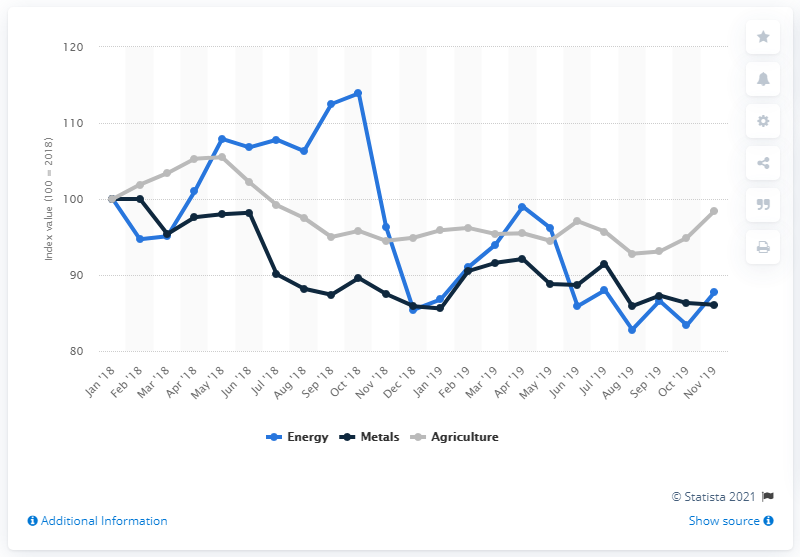Give some essential details in this illustration. In November 2019, the commodity index for energy was 87.7. The commodity index for agriculture in November 2019 was 98.4. 